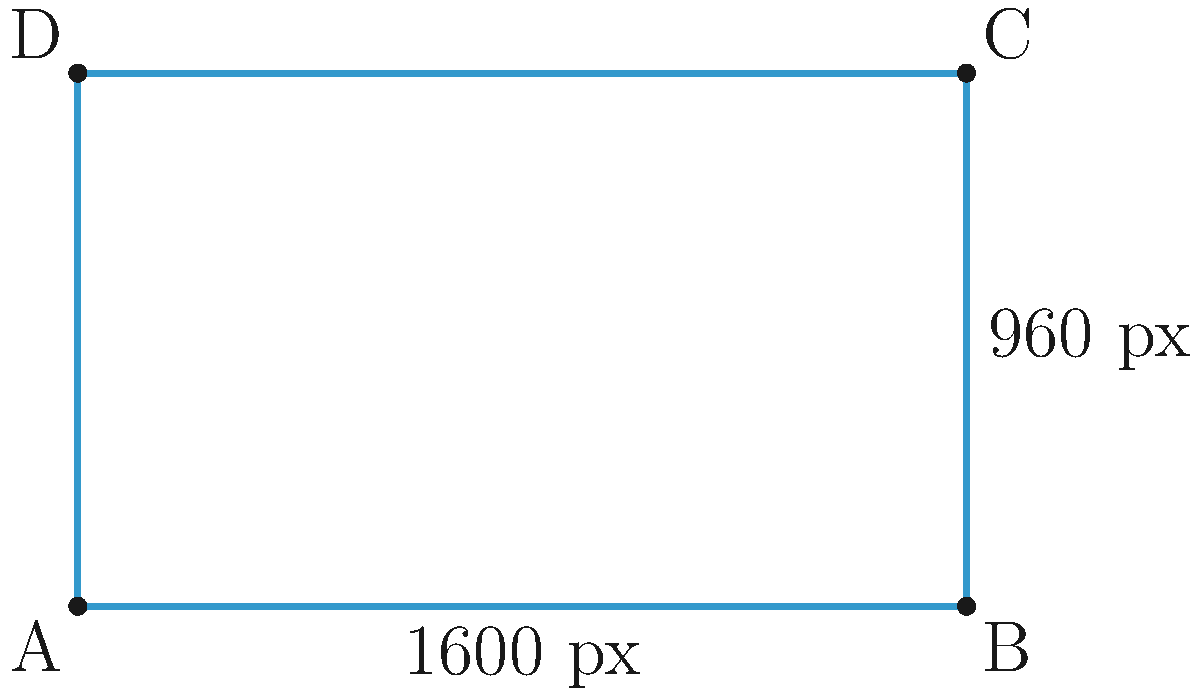As a graphic designer, you're working on a project with Pauline that requires a specific aspect ratio for images. You have a rectangular image with dimensions 1600 pixels wide and 960 pixels tall. What is the aspect ratio of this image when expressed in its simplest form (i.e., as a ratio of two integers)? To find the aspect ratio, we need to follow these steps:

1) The aspect ratio is the ratio of width to height. In this case:
   Width : Height = 1600 : 960

2) To simplify this ratio, we need to find the greatest common divisor (GCD) of 1600 and 960.

3) We can use the Euclidean algorithm to find the GCD:
   1600 = 1 × 960 + 640
   960 = 1 × 640 + 320
   640 = 2 × 320 + 0
   
   Therefore, the GCD is 320.

4) Now, divide both numbers by the GCD:
   1600 ÷ 320 = 5
   960 ÷ 320 = 3

5) Thus, the simplified aspect ratio is 5:3.

This means for every 5 units of width, there are 3 units of height in this image.
Answer: 5:3 